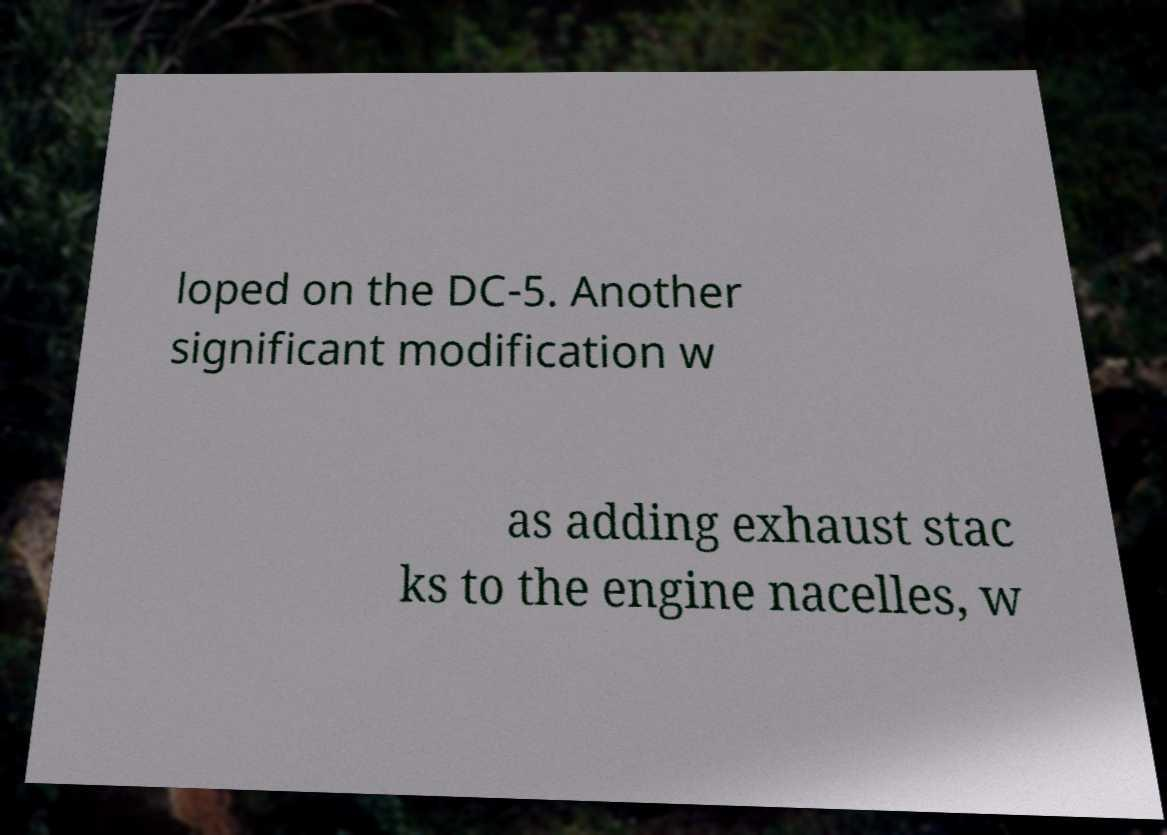Could you extract and type out the text from this image? loped on the DC-5. Another significant modification w as adding exhaust stac ks to the engine nacelles, w 